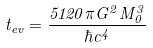<formula> <loc_0><loc_0><loc_500><loc_500>t _ { e v } = \frac { 5 1 2 0 \pi G ^ { 2 } M _ { 0 } ^ { 3 } } { \hbar { c } ^ { 4 } }</formula> 